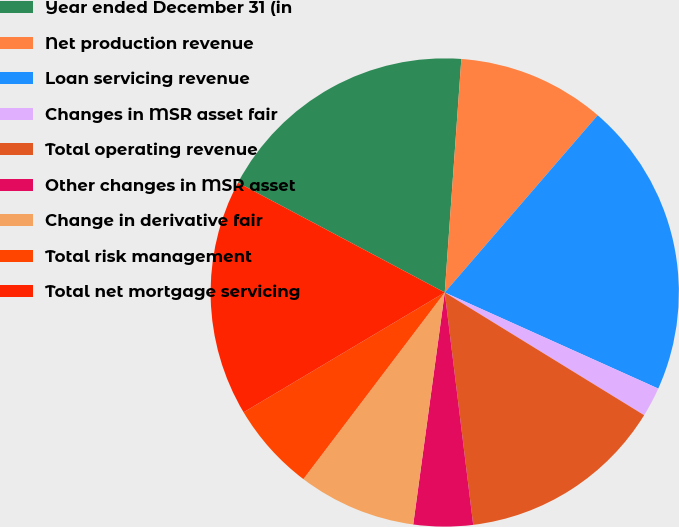Convert chart to OTSL. <chart><loc_0><loc_0><loc_500><loc_500><pie_chart><fcel>Year ended December 31 (in<fcel>Net production revenue<fcel>Loan servicing revenue<fcel>Changes in MSR asset fair<fcel>Total operating revenue<fcel>Other changes in MSR asset<fcel>Change in derivative fair<fcel>Total risk management<fcel>Total net mortgage servicing<nl><fcel>18.36%<fcel>10.2%<fcel>20.4%<fcel>2.05%<fcel>14.28%<fcel>4.09%<fcel>8.17%<fcel>6.13%<fcel>16.32%<nl></chart> 